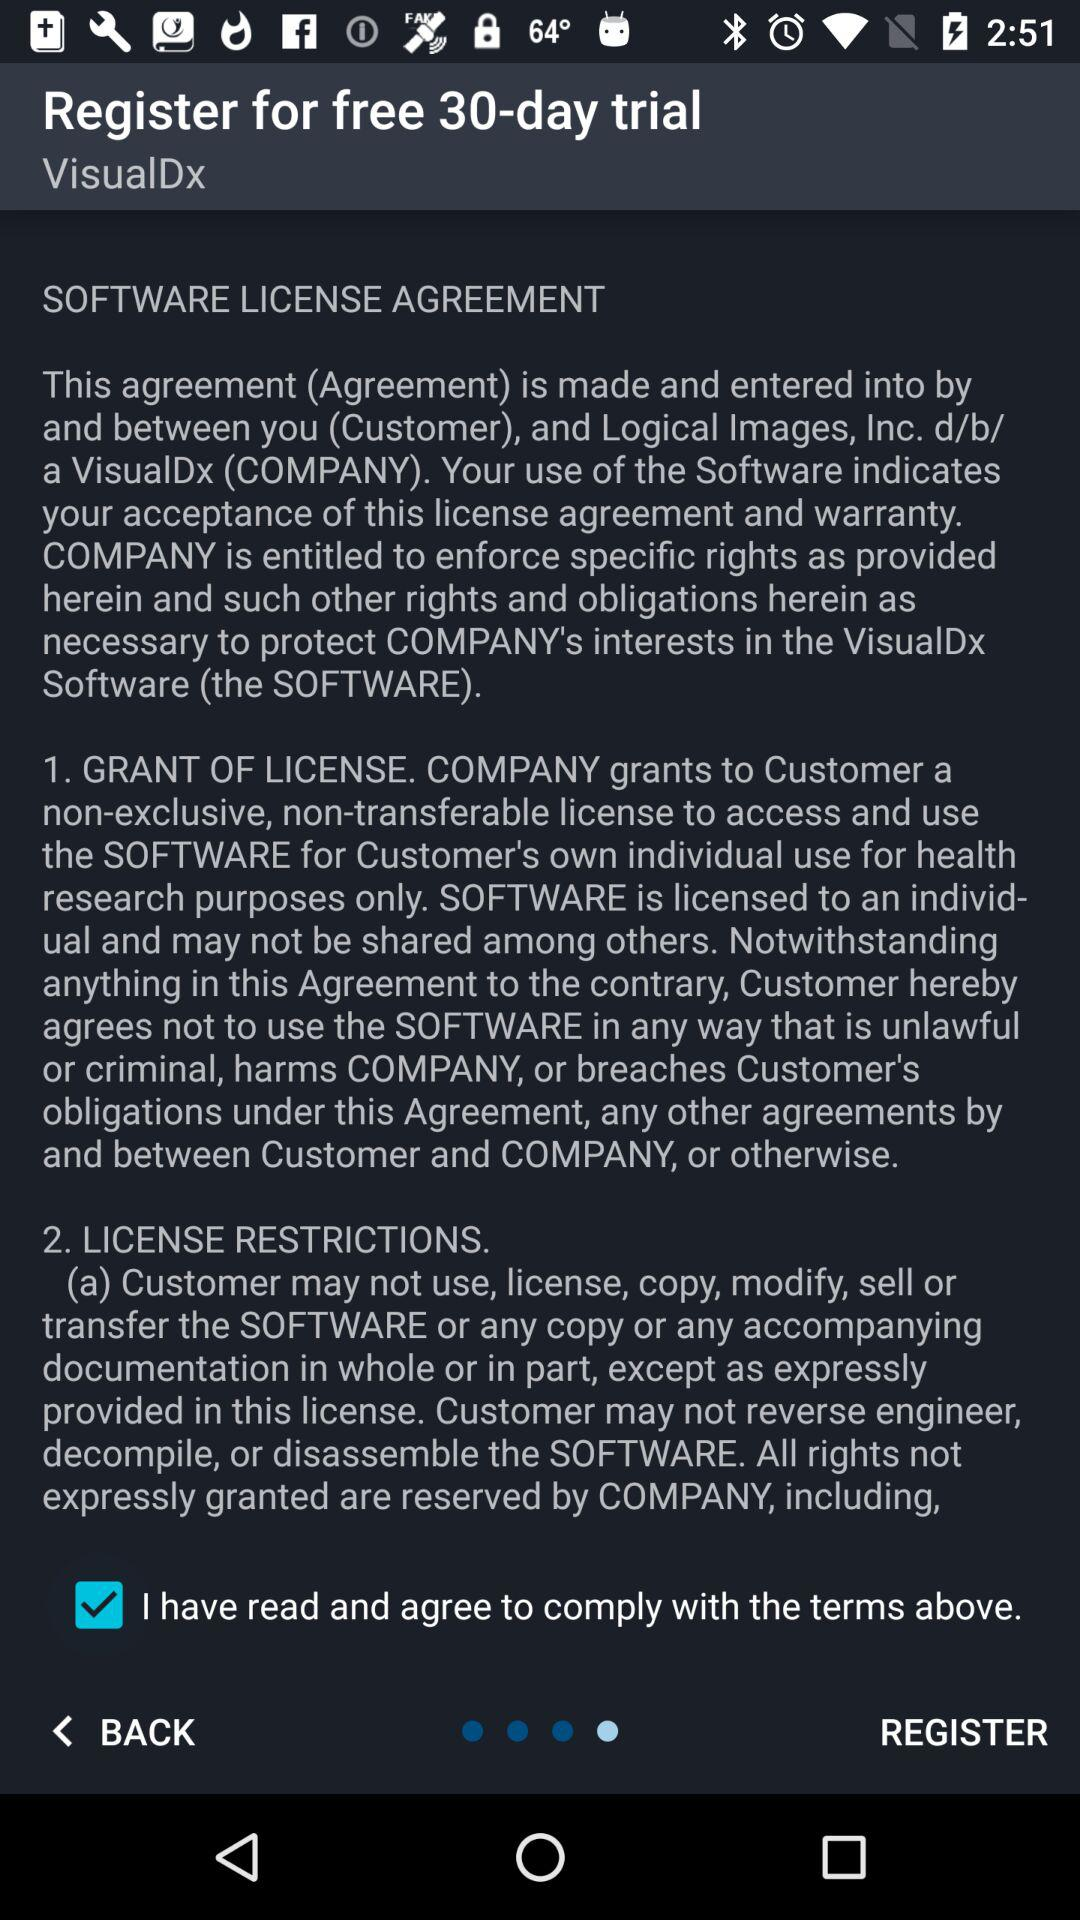How many sections are there in the license agreement?
Answer the question using a single word or phrase. 2 